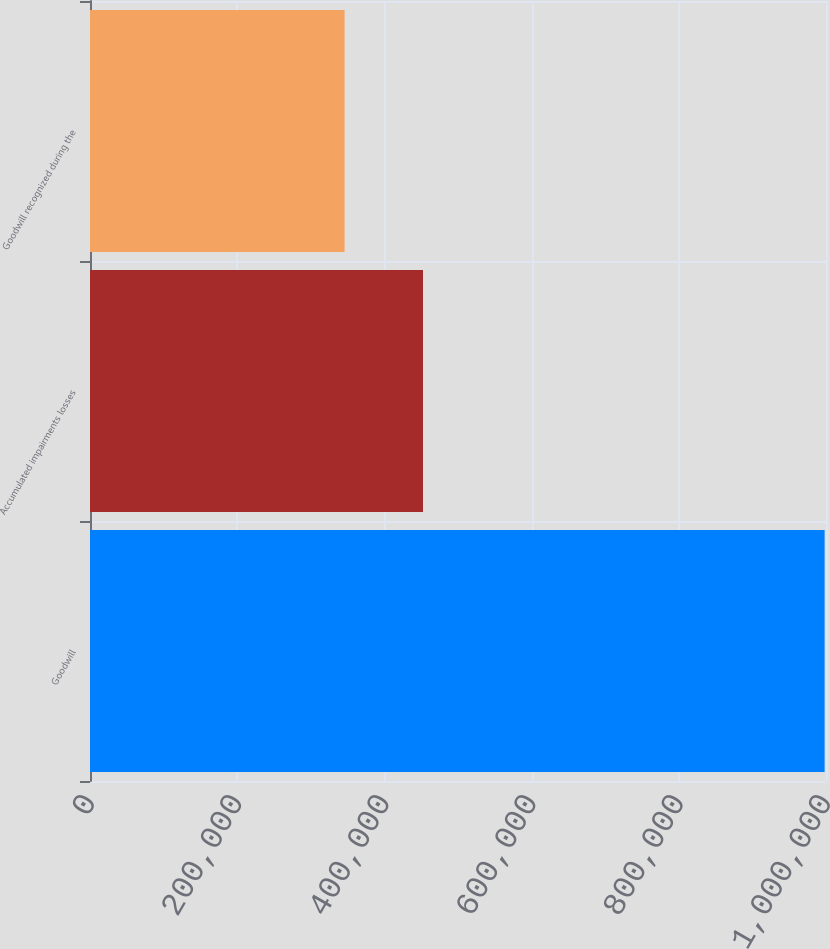<chart> <loc_0><loc_0><loc_500><loc_500><bar_chart><fcel>Goodwill<fcel>Accumulated impairments losses<fcel>Goodwill recognized during the<nl><fcel>998130<fcel>452441<fcel>345905<nl></chart> 